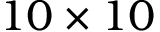<formula> <loc_0><loc_0><loc_500><loc_500>1 0 \times 1 0</formula> 